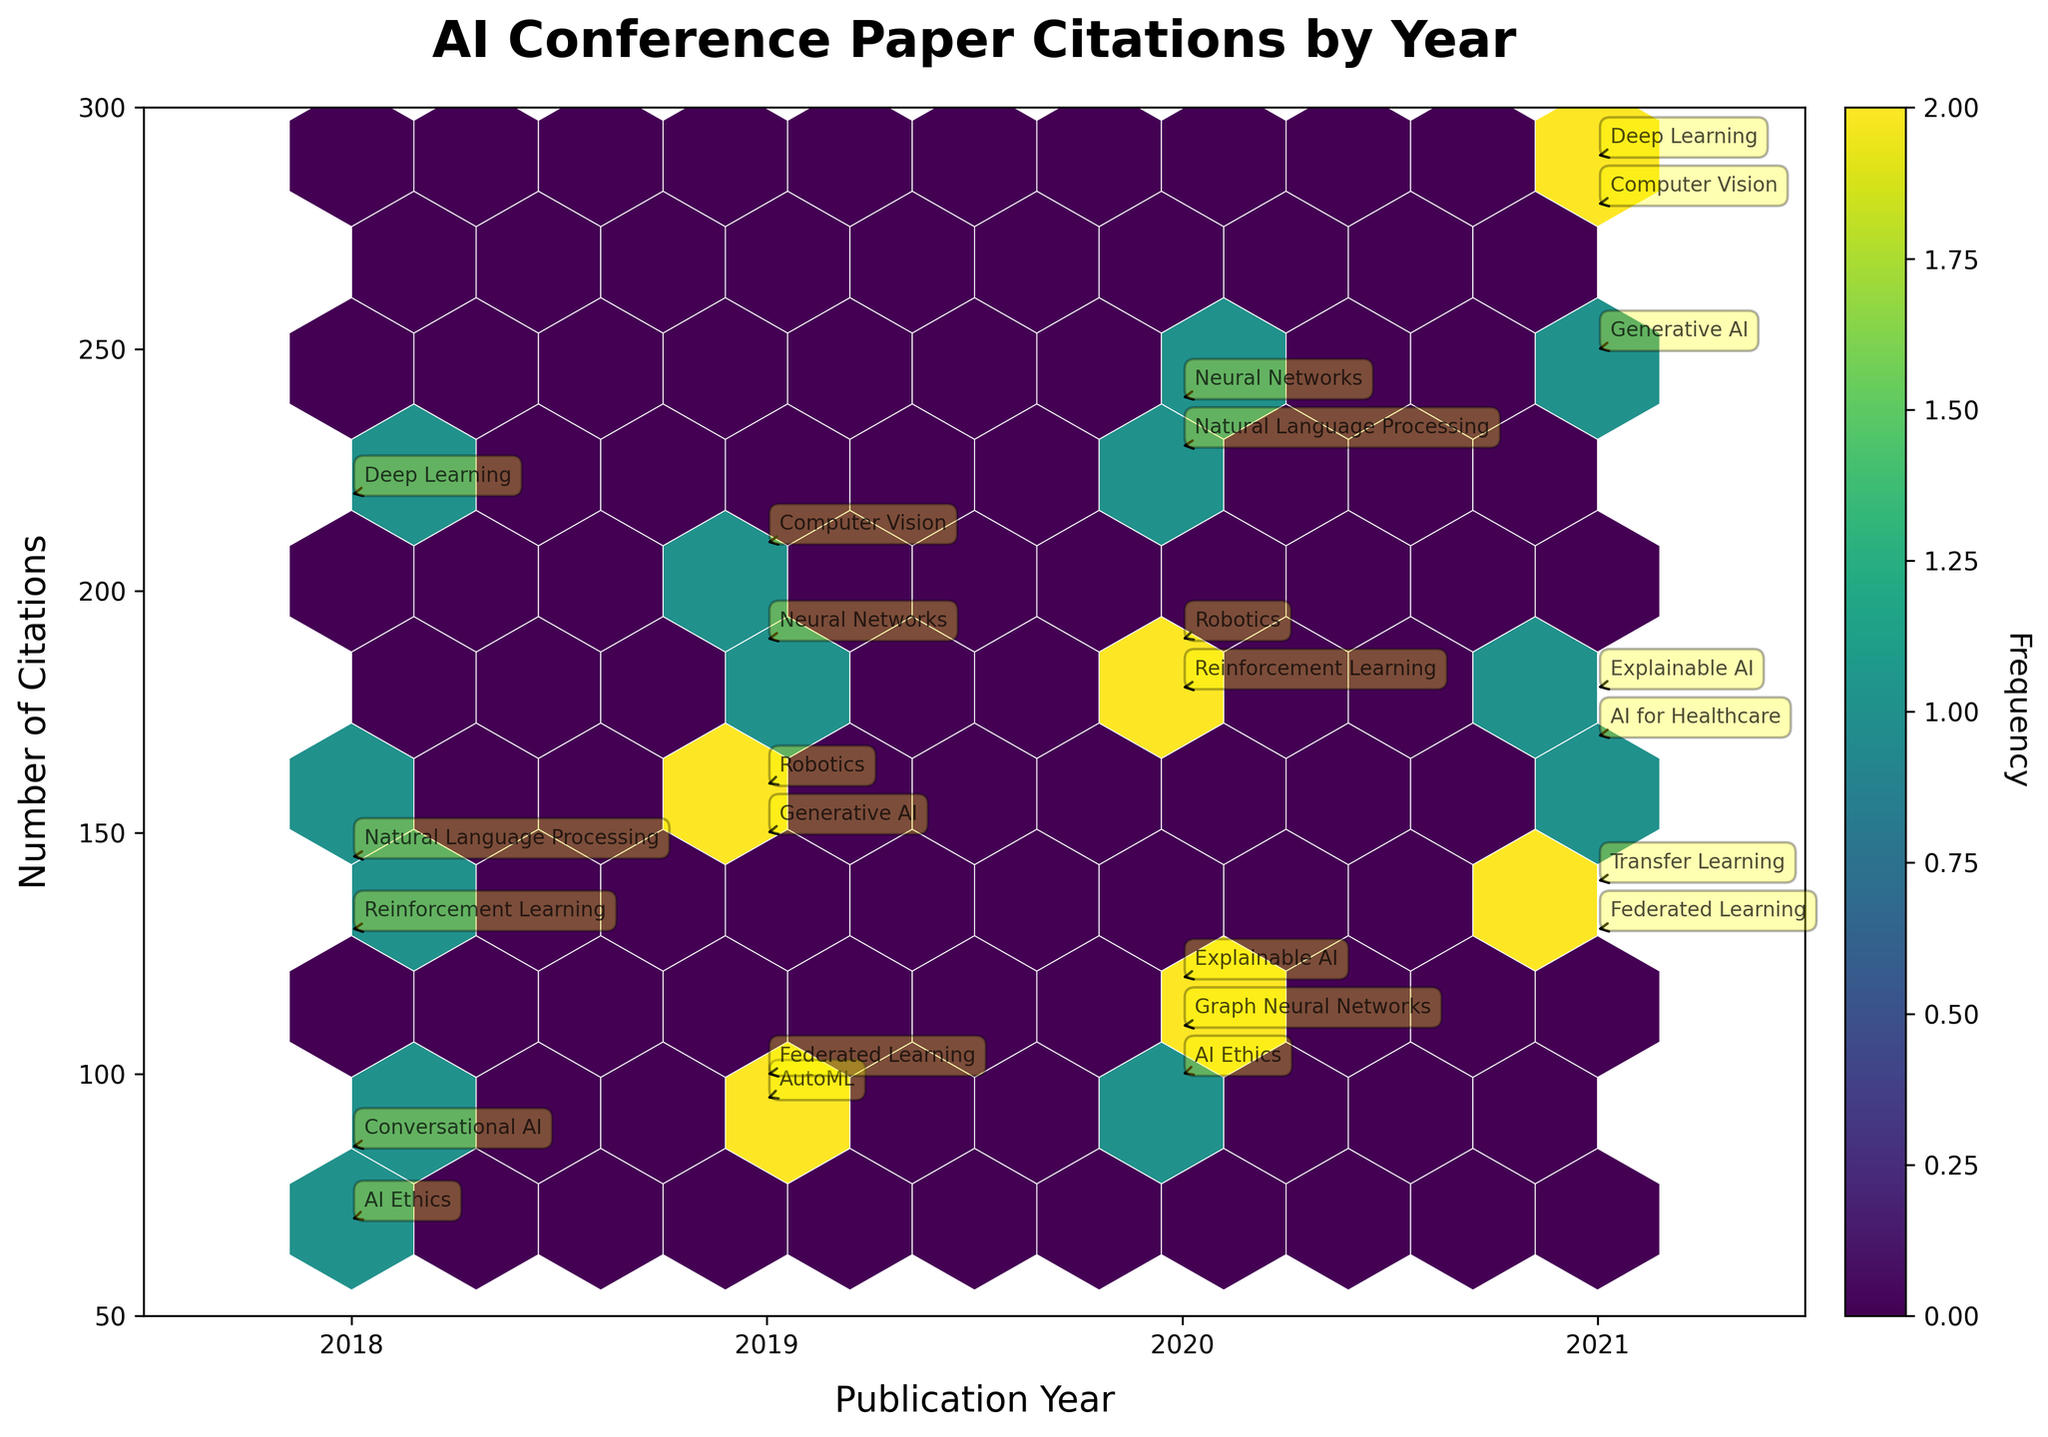what is the title of the plot? The title of the plot is usually found at the top of the figure. In this case, it is placed prominently in bold and larger font size. The title is meant to provide context for what the plot is about.
Answer: AI Conference Paper Citations by Year what are the axes labels in the plot? The axes labels give information about what each axis represents. The x-axis is labeled "Publication Year" and the y-axis is labeled "Number of Citations." These labels indicate that the plot shows the relationship between the year of publication and the number of citations.
Answer: Publication Year, Number of Citations how many distinct years are represented in the data? One can determine the distinct years by looking at the x-axis ticks or directly at the data points spread along the x-axis. The x-axis shows ticks for each year from 2018 to 2021.
Answer: 4 what range of citations is covered on the y-axis? The y-axis range can be determined by looking at the y-axis limits. The minimum value is 50, and the maximum value is 300, as displayed on the y-axis.
Answer: 50 to 300 which year had the highest frequency of papers with more than 250 citations? To answer this, one needs to look at the color density and the annotations within the hexagons that are above 250 citations. According to the hexbin colors, the highest frequency for citations above 250 occurs in 2021.
Answer: 2021 how many topics have citations equal to or greater than 200 in 2018? To answer this, check the annotations and y-values for the year 2018 specifically. According to the data points for the year 2018 with citations equal to or greater than 200, there are two topics: "Deep Learning" and "Natural Language Processing".
Answer: 2 compare the number of citations for "AI Ethics" in 2018 and 2020. Which year had more? To compare the citations for "AI Ethics" across two years, we need to check the annotations for these years. In 2018, "AI Ethics" had 70 citations, while in 2020, it had 100 citations. Clearly, 2020 had more citations.
Answer: 2020 how are the colors used in the hexbin plot indicative of citation frequency? In a hexbin plot, the color intensity indicates the frequency of data points within each hexagon. The deeper or more saturated the color, the higher the concentration of data points. This helps to quickly understand where there are higher frequencies or densities of citations.
Answer: Color intensity indicates frequency identify and compare the number of citations for "Deep Learning" in 2018 and 2021. Annotations for "Deep Learning" will show the specific citations for each year. In 2018, "Deep Learning" had 220 citations, and in 2021, it had 290 citations. Comparing these values, 2021 had more citations.
Answer: 2021 which topic had the highest number of citations in 2019? By checking the annotations for the year 2019, each data point's y-value tells us the number of citations. The topic with the highest y-value for 2019 is "Computer Vision" with 210 citations.
Answer: Computer Vision 